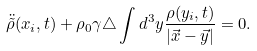<formula> <loc_0><loc_0><loc_500><loc_500>\ddot { \tilde { \rho } } ( x _ { i } , t ) + \rho _ { 0 } \gamma \triangle \int d ^ { 3 } y \frac { \rho ( y _ { i } , t ) } { | \vec { x } - \vec { y } | } = 0 .</formula> 